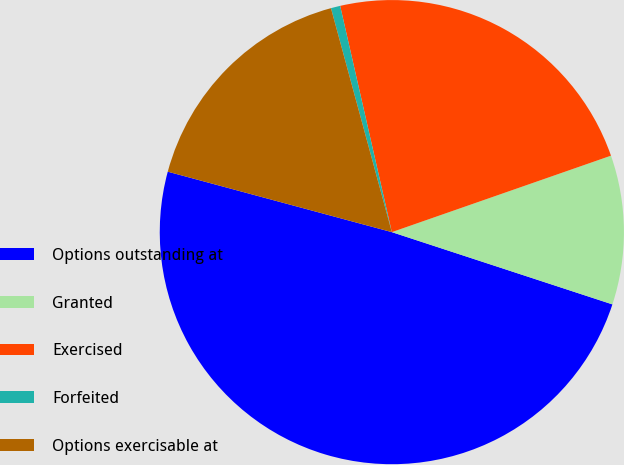Convert chart to OTSL. <chart><loc_0><loc_0><loc_500><loc_500><pie_chart><fcel>Options outstanding at<fcel>Granted<fcel>Exercised<fcel>Forfeited<fcel>Options exercisable at<nl><fcel>49.15%<fcel>10.38%<fcel>23.23%<fcel>0.65%<fcel>16.58%<nl></chart> 